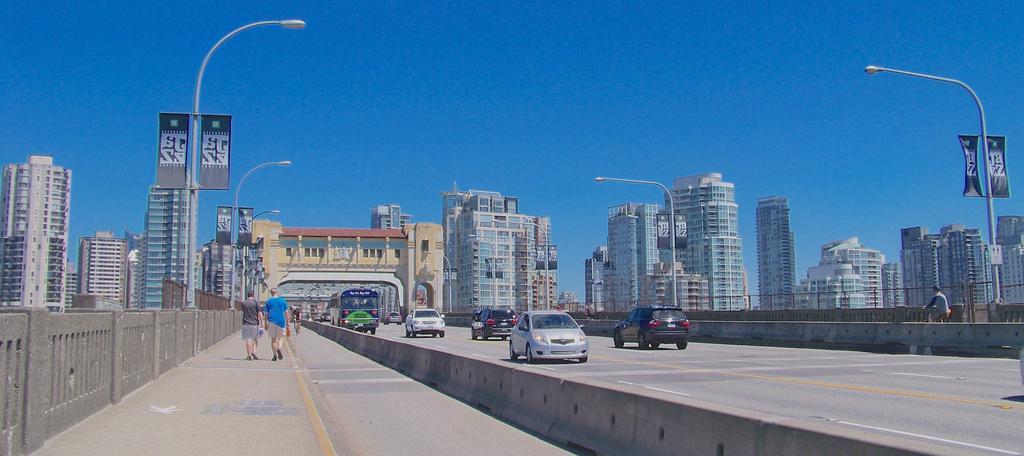Please provide a concise description of this image. In this image we can see persons walking on the road, persons riding bicycles, motor vehicles on the road, street poles, street lights, advertisement boards, buildings, barrier grills and sky. 